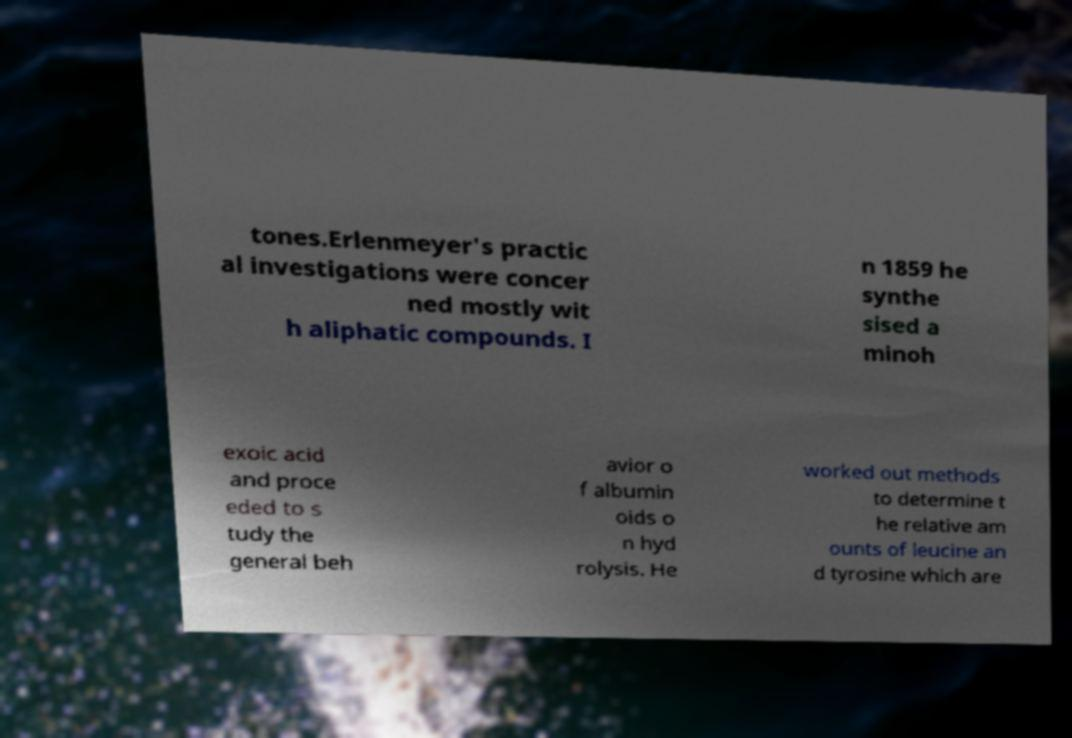Please read and relay the text visible in this image. What does it say? tones.Erlenmeyer's practic al investigations were concer ned mostly wit h aliphatic compounds. I n 1859 he synthe sised a minoh exoic acid and proce eded to s tudy the general beh avior o f albumin oids o n hyd rolysis. He worked out methods to determine t he relative am ounts of leucine an d tyrosine which are 